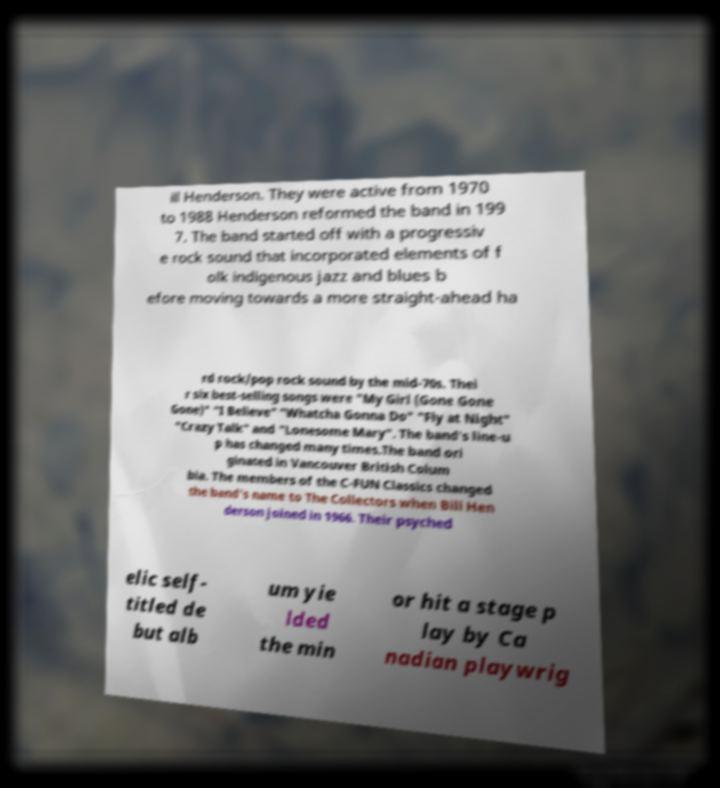What messages or text are displayed in this image? I need them in a readable, typed format. ill Henderson. They were active from 1970 to 1988 Henderson reformed the band in 199 7. The band started off with a progressiv e rock sound that incorporated elements of f olk indigenous jazz and blues b efore moving towards a more straight-ahead ha rd rock/pop rock sound by the mid-70s. Thei r six best-selling songs were "My Girl (Gone Gone Gone)" "I Believe" "Whatcha Gonna Do" "Fly at Night" "Crazy Talk" and "Lonesome Mary". The band's line-u p has changed many times.The band ori ginated in Vancouver British Colum bia. The members of the C-FUN Classics changed the band's name to The Collectors when Bill Hen derson joined in 1966. Their psyched elic self- titled de but alb um yie lded the min or hit a stage p lay by Ca nadian playwrig 